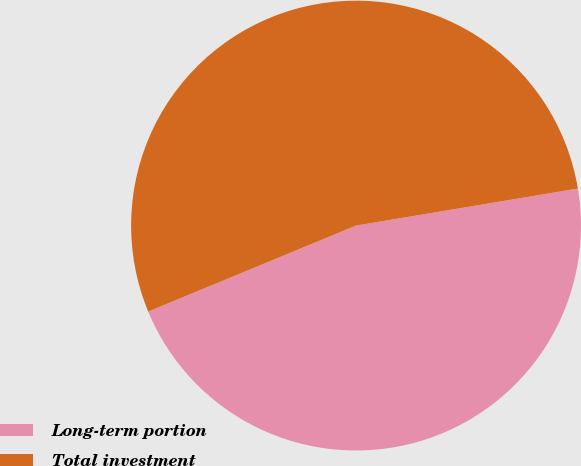Convert chart. <chart><loc_0><loc_0><loc_500><loc_500><pie_chart><fcel>Long-term portion<fcel>Total investment<nl><fcel>46.39%<fcel>53.61%<nl></chart> 